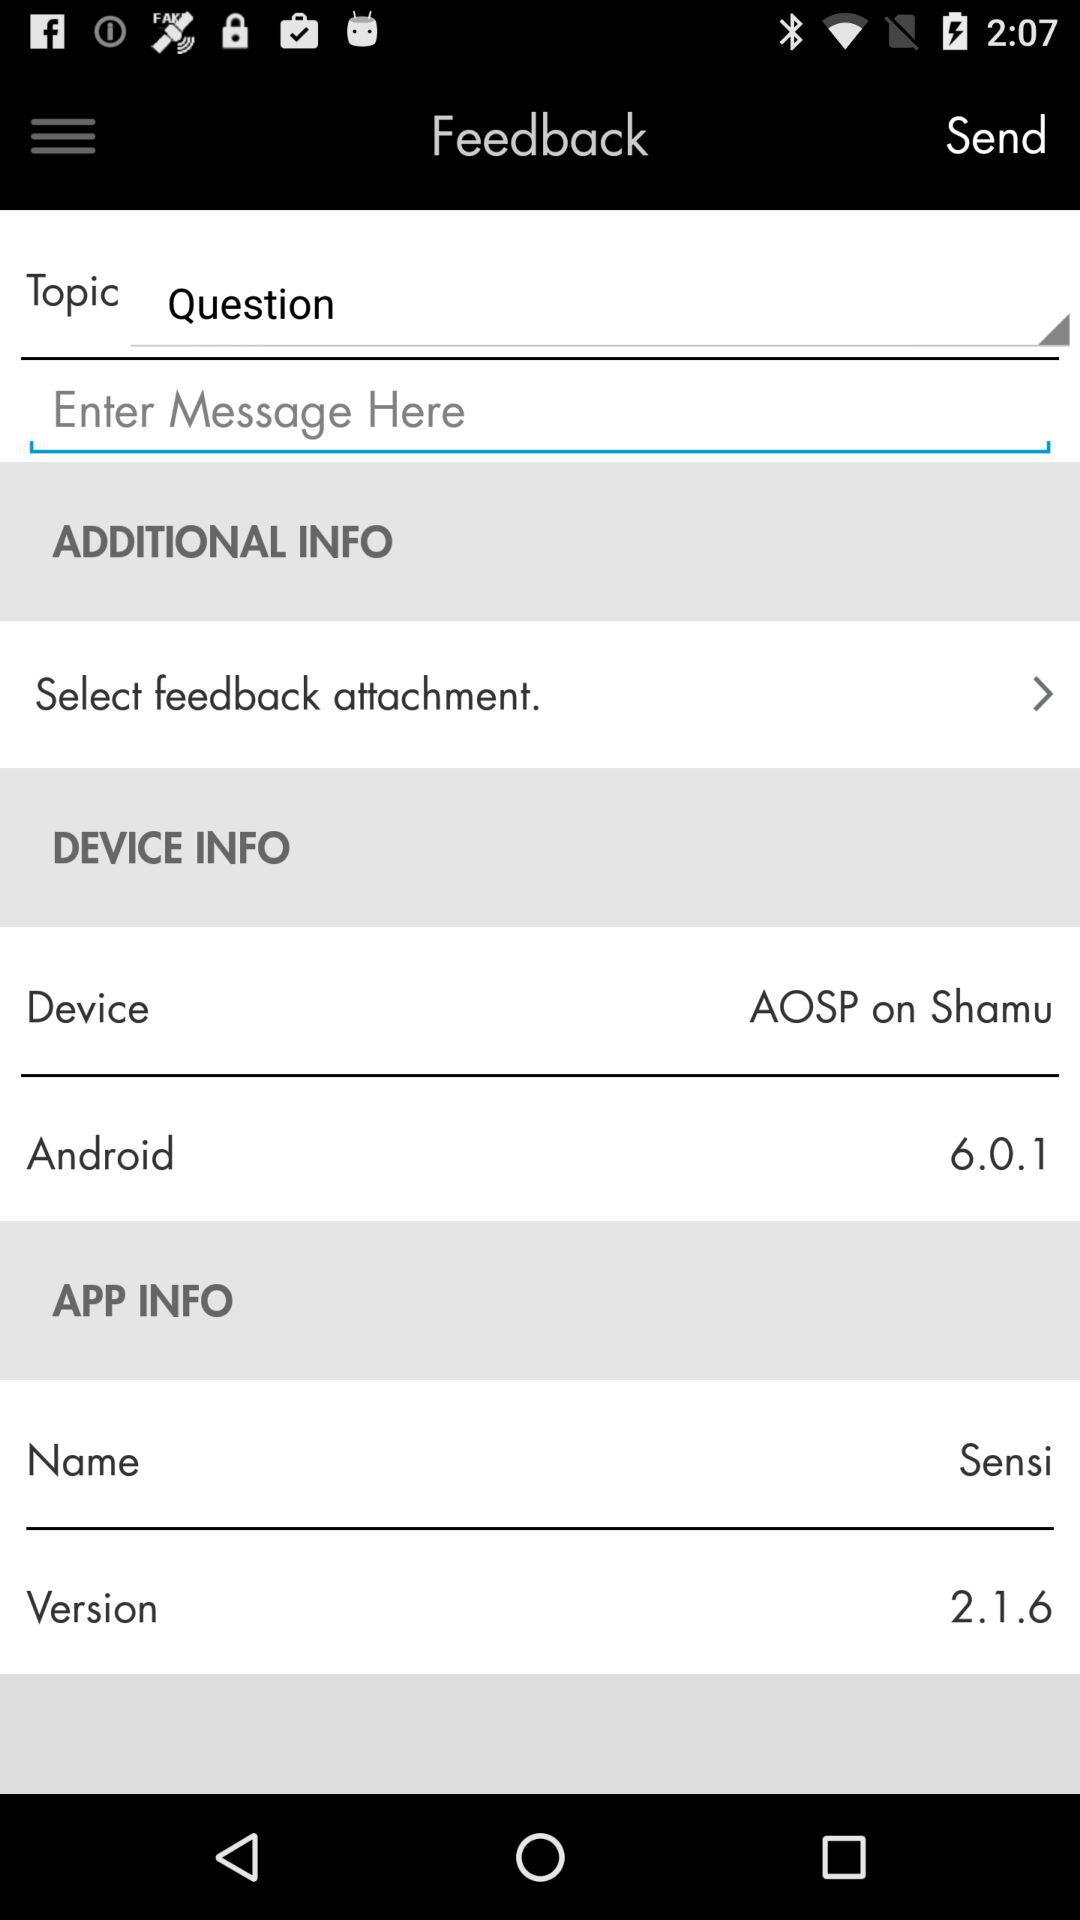What app version is displayed?
Answer the question using a single word or phrase. The version is 2.1.6 